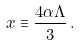<formula> <loc_0><loc_0><loc_500><loc_500>x \equiv \frac { 4 \alpha \Lambda } { 3 } \, .</formula> 